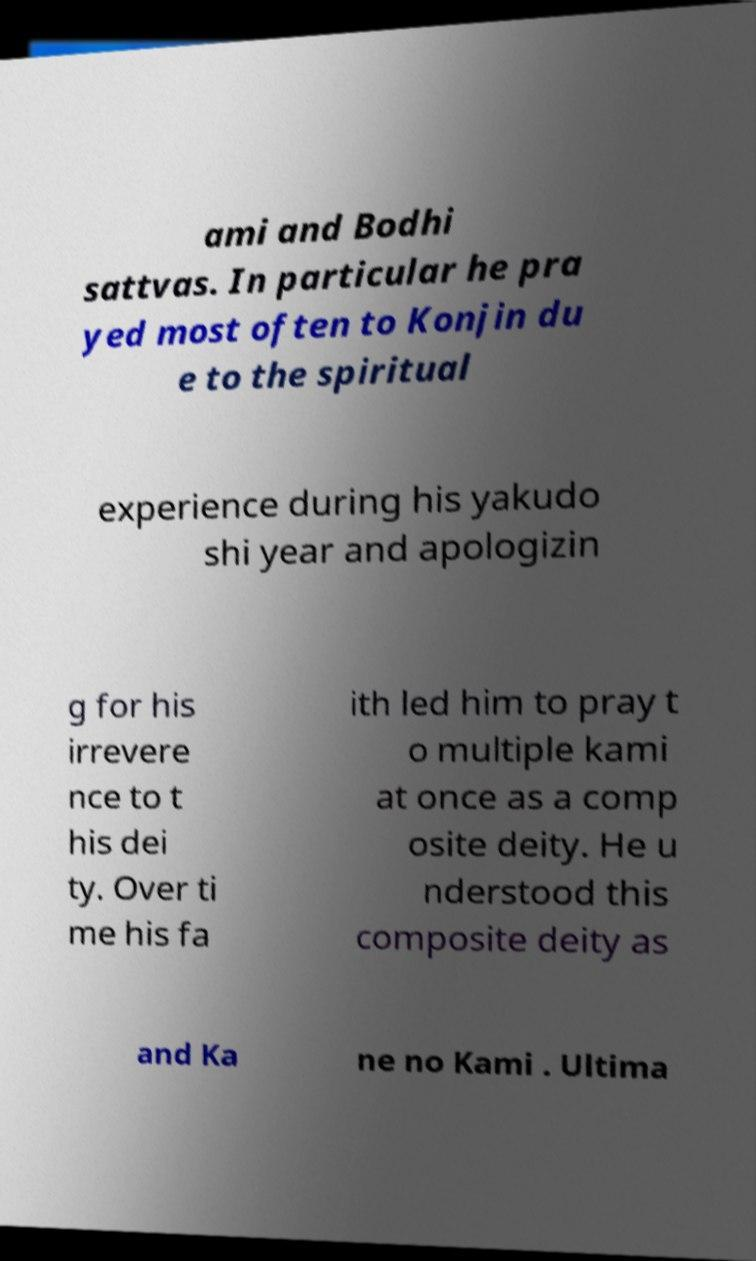I need the written content from this picture converted into text. Can you do that? ami and Bodhi sattvas. In particular he pra yed most often to Konjin du e to the spiritual experience during his yakudo shi year and apologizin g for his irrevere nce to t his dei ty. Over ti me his fa ith led him to pray t o multiple kami at once as a comp osite deity. He u nderstood this composite deity as and Ka ne no Kami . Ultima 